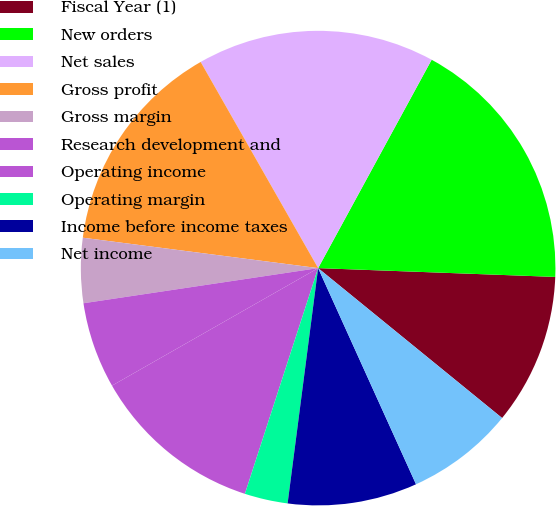Convert chart. <chart><loc_0><loc_0><loc_500><loc_500><pie_chart><fcel>Fiscal Year (1)<fcel>New orders<fcel>Net sales<fcel>Gross profit<fcel>Gross margin<fcel>Research development and<fcel>Operating income<fcel>Operating margin<fcel>Income before income taxes<fcel>Net income<nl><fcel>10.29%<fcel>17.65%<fcel>16.18%<fcel>14.71%<fcel>4.41%<fcel>5.88%<fcel>11.76%<fcel>2.94%<fcel>8.82%<fcel>7.35%<nl></chart> 